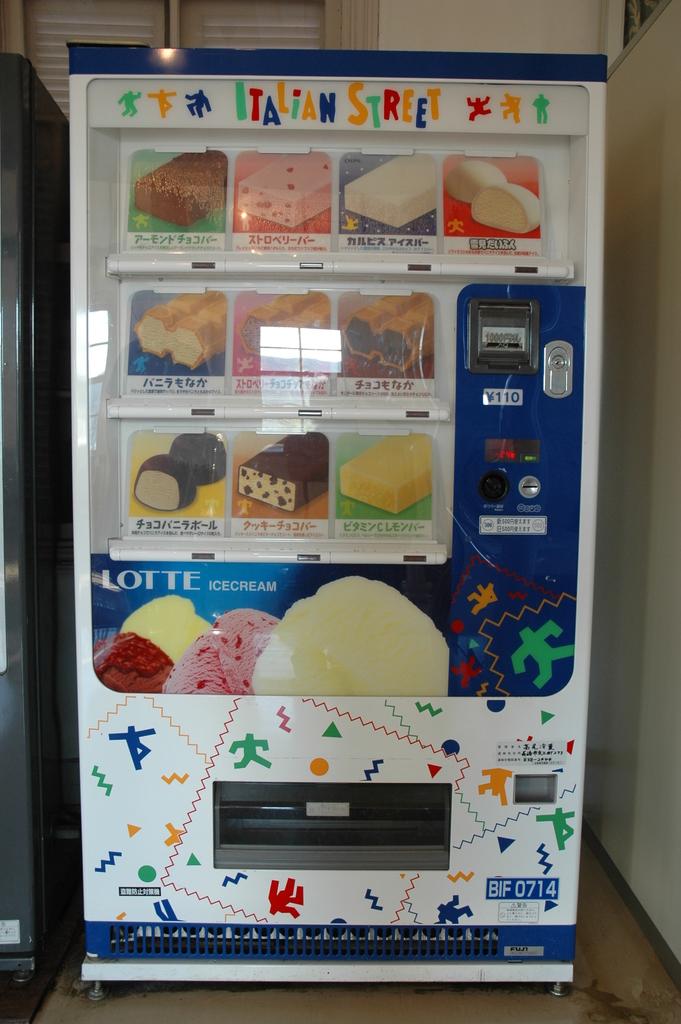What does it say at the top of the vending machine?
Ensure brevity in your answer.  Italian street. What kind of frozen treat is served?
Offer a terse response. Ice cream. 